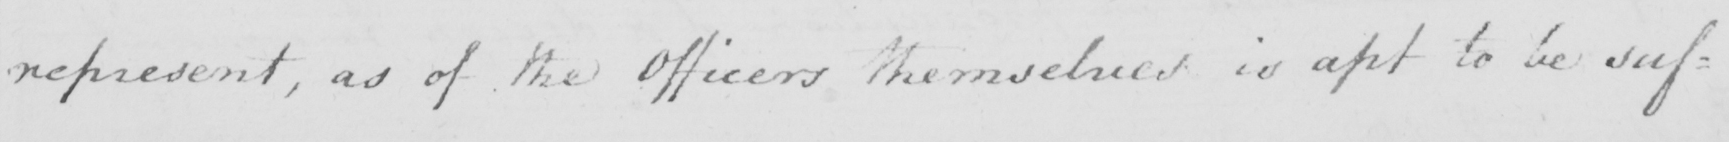Can you read and transcribe this handwriting? represent , as of the Officers themselves is apt to be suf= 